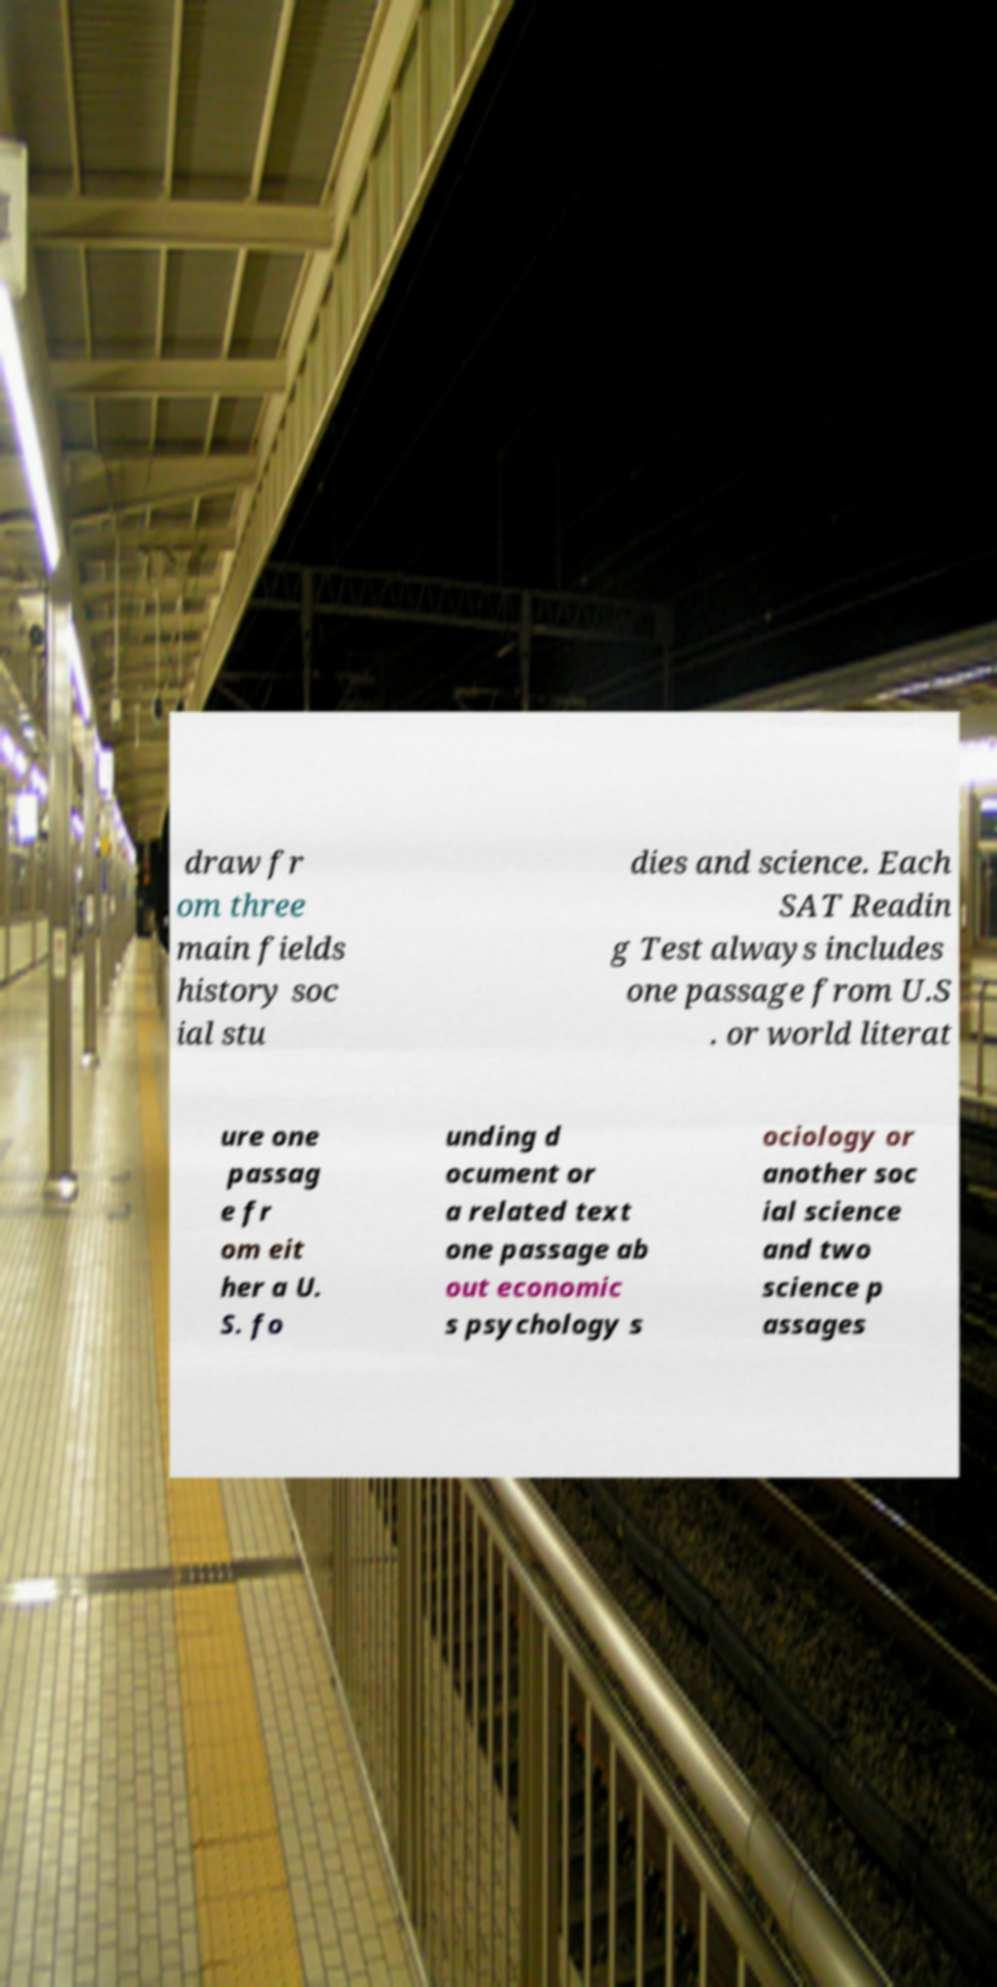I need the written content from this picture converted into text. Can you do that? draw fr om three main fields history soc ial stu dies and science. Each SAT Readin g Test always includes one passage from U.S . or world literat ure one passag e fr om eit her a U. S. fo unding d ocument or a related text one passage ab out economic s psychology s ociology or another soc ial science and two science p assages 